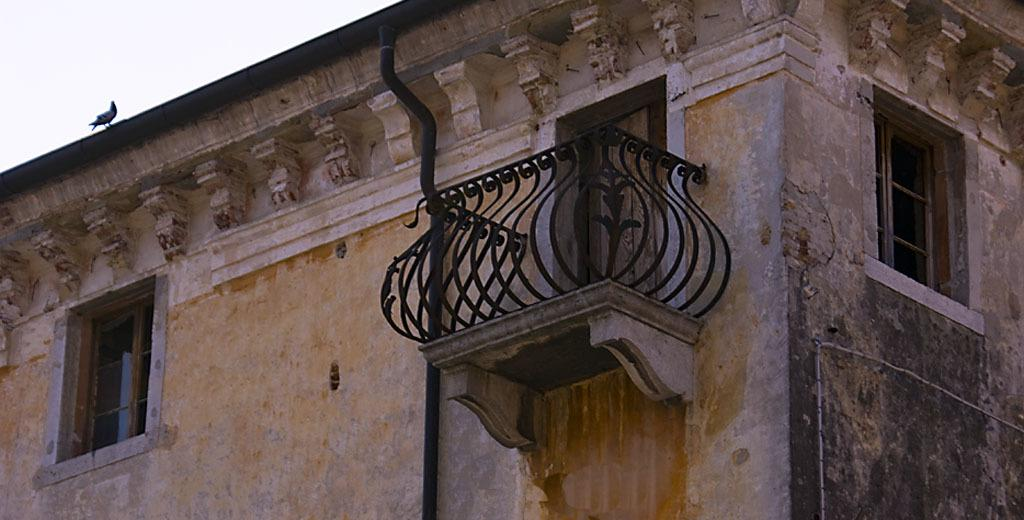What type of structure is visible in the image? There is a building in the image. What features can be seen on the building? The building has windows and a door. Is there any additional detail near the door? Yes, there is a railing near the door. Are there any animals present in the image? Yes, there is a pigeon on the wall. What type of fairies can be seen flying around the building in the image? There are no fairies present in the image; it only features a building, windows, a door, a railing, and a pigeon. 